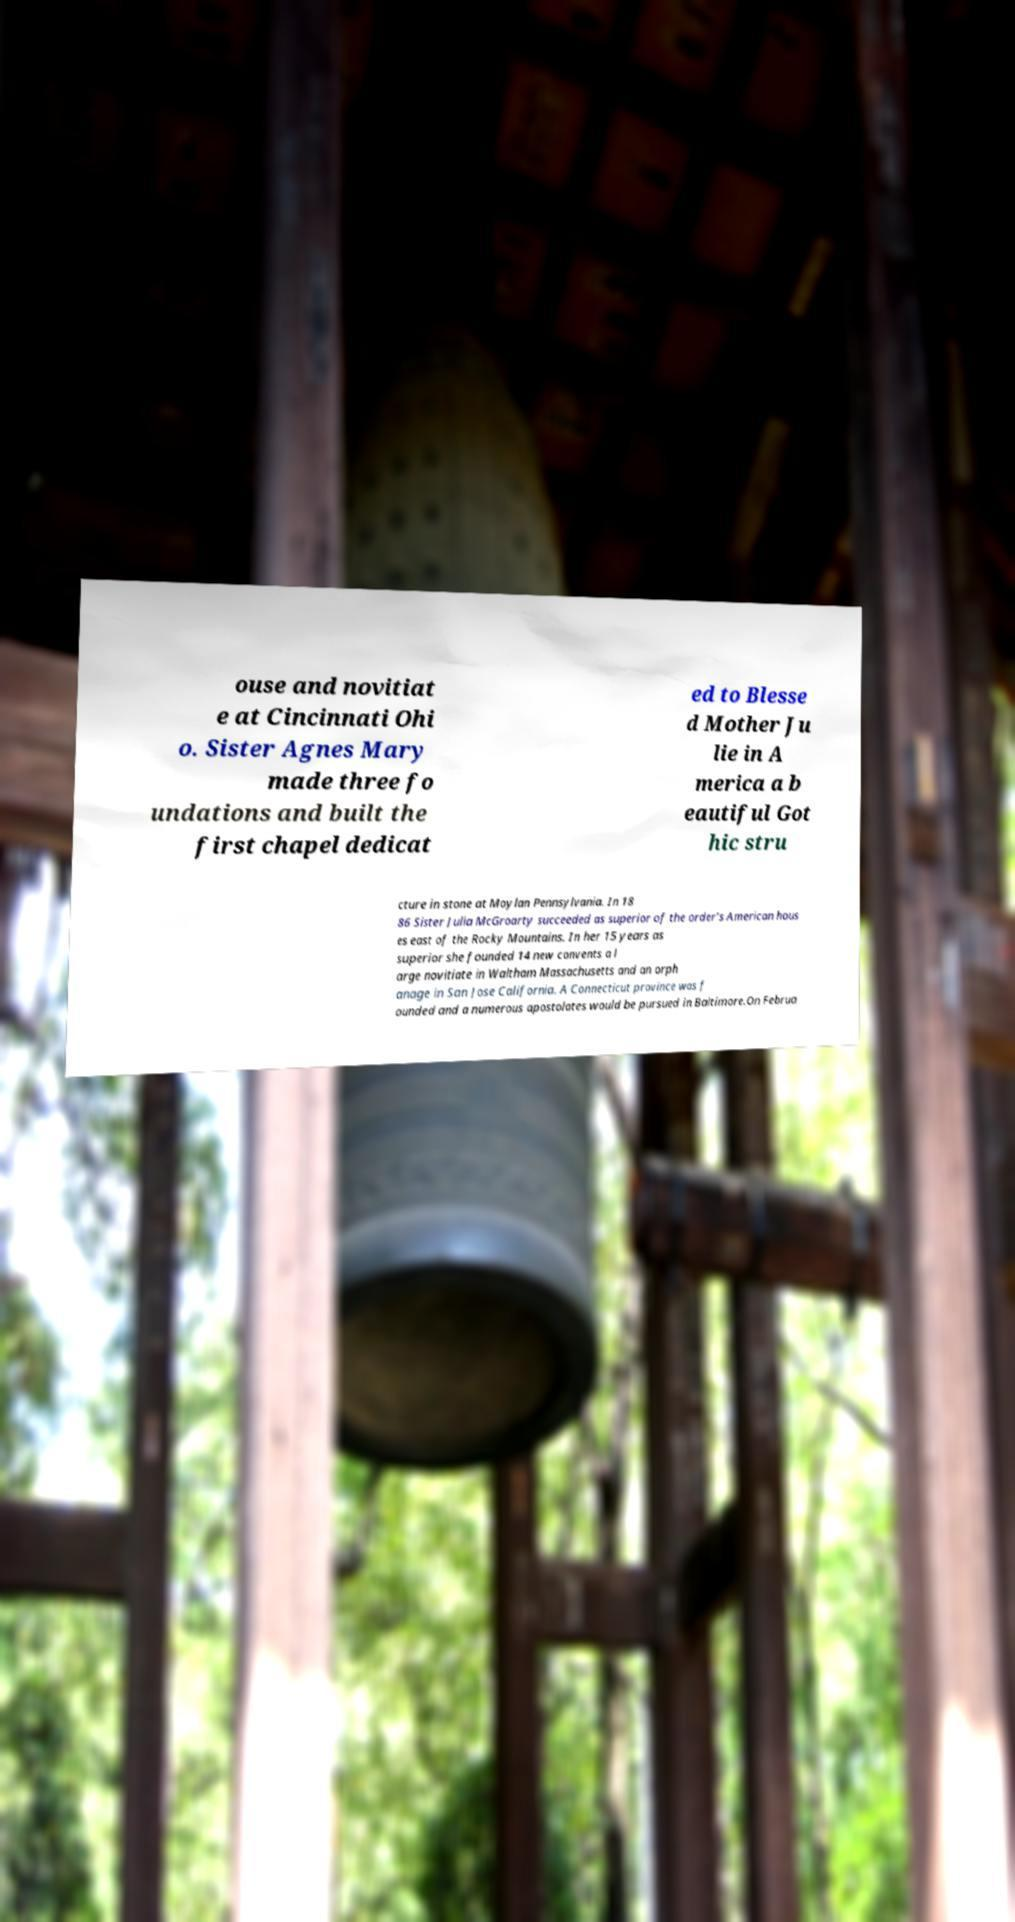For documentation purposes, I need the text within this image transcribed. Could you provide that? ouse and novitiat e at Cincinnati Ohi o. Sister Agnes Mary made three fo undations and built the first chapel dedicat ed to Blesse d Mother Ju lie in A merica a b eautiful Got hic stru cture in stone at Moylan Pennsylvania. In 18 86 Sister Julia McGroarty succeeded as superior of the order’s American hous es east of the Rocky Mountains. In her 15 years as superior she founded 14 new convents a l arge novitiate in Waltham Massachusetts and an orph anage in San Jose California. A Connecticut province was f ounded and a numerous apostolates would be pursued in Baltimore.On Februa 